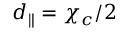<formula> <loc_0><loc_0><loc_500><loc_500>d _ { \| } = \chi _ { c } / 2</formula> 